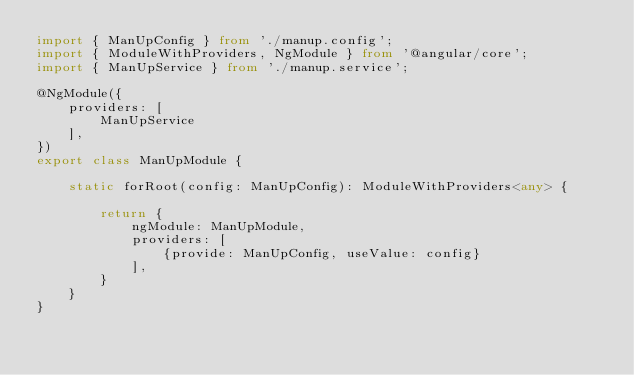<code> <loc_0><loc_0><loc_500><loc_500><_TypeScript_>import { ManUpConfig } from './manup.config';
import { ModuleWithProviders, NgModule } from '@angular/core';
import { ManUpService } from './manup.service';

@NgModule({
    providers: [
        ManUpService
    ],
})
export class ManUpModule {

    static forRoot(config: ManUpConfig): ModuleWithProviders<any> {

        return {
            ngModule: ManUpModule,
            providers: [
                {provide: ManUpConfig, useValue: config}
            ],
        }
    }
}
</code> 